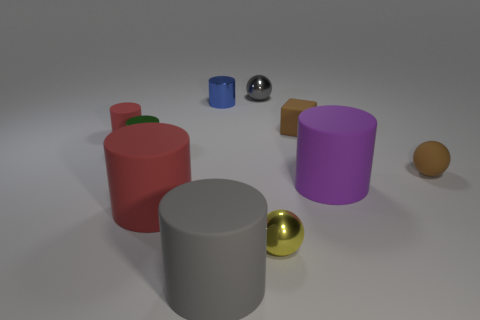How many other things are the same material as the yellow sphere?
Offer a terse response. 3. How many small green matte things are there?
Offer a terse response. 0. What number of objects are big gray cylinders or tiny objects that are behind the yellow metallic ball?
Provide a succinct answer. 7. Is there any other thing that has the same shape as the small blue object?
Provide a succinct answer. Yes. There is a cylinder that is to the right of the gray metallic ball; does it have the same size as the large gray thing?
Give a very brief answer. Yes. How many rubber objects are big purple objects or red objects?
Your answer should be compact. 3. What size is the shiny cylinder on the left side of the small blue thing?
Make the answer very short. Small. Is the blue shiny object the same shape as the green object?
Provide a short and direct response. Yes. How many large objects are either purple matte things or red metal balls?
Offer a terse response. 1. Are there any yellow metal objects behind the blue shiny cylinder?
Provide a short and direct response. No. 